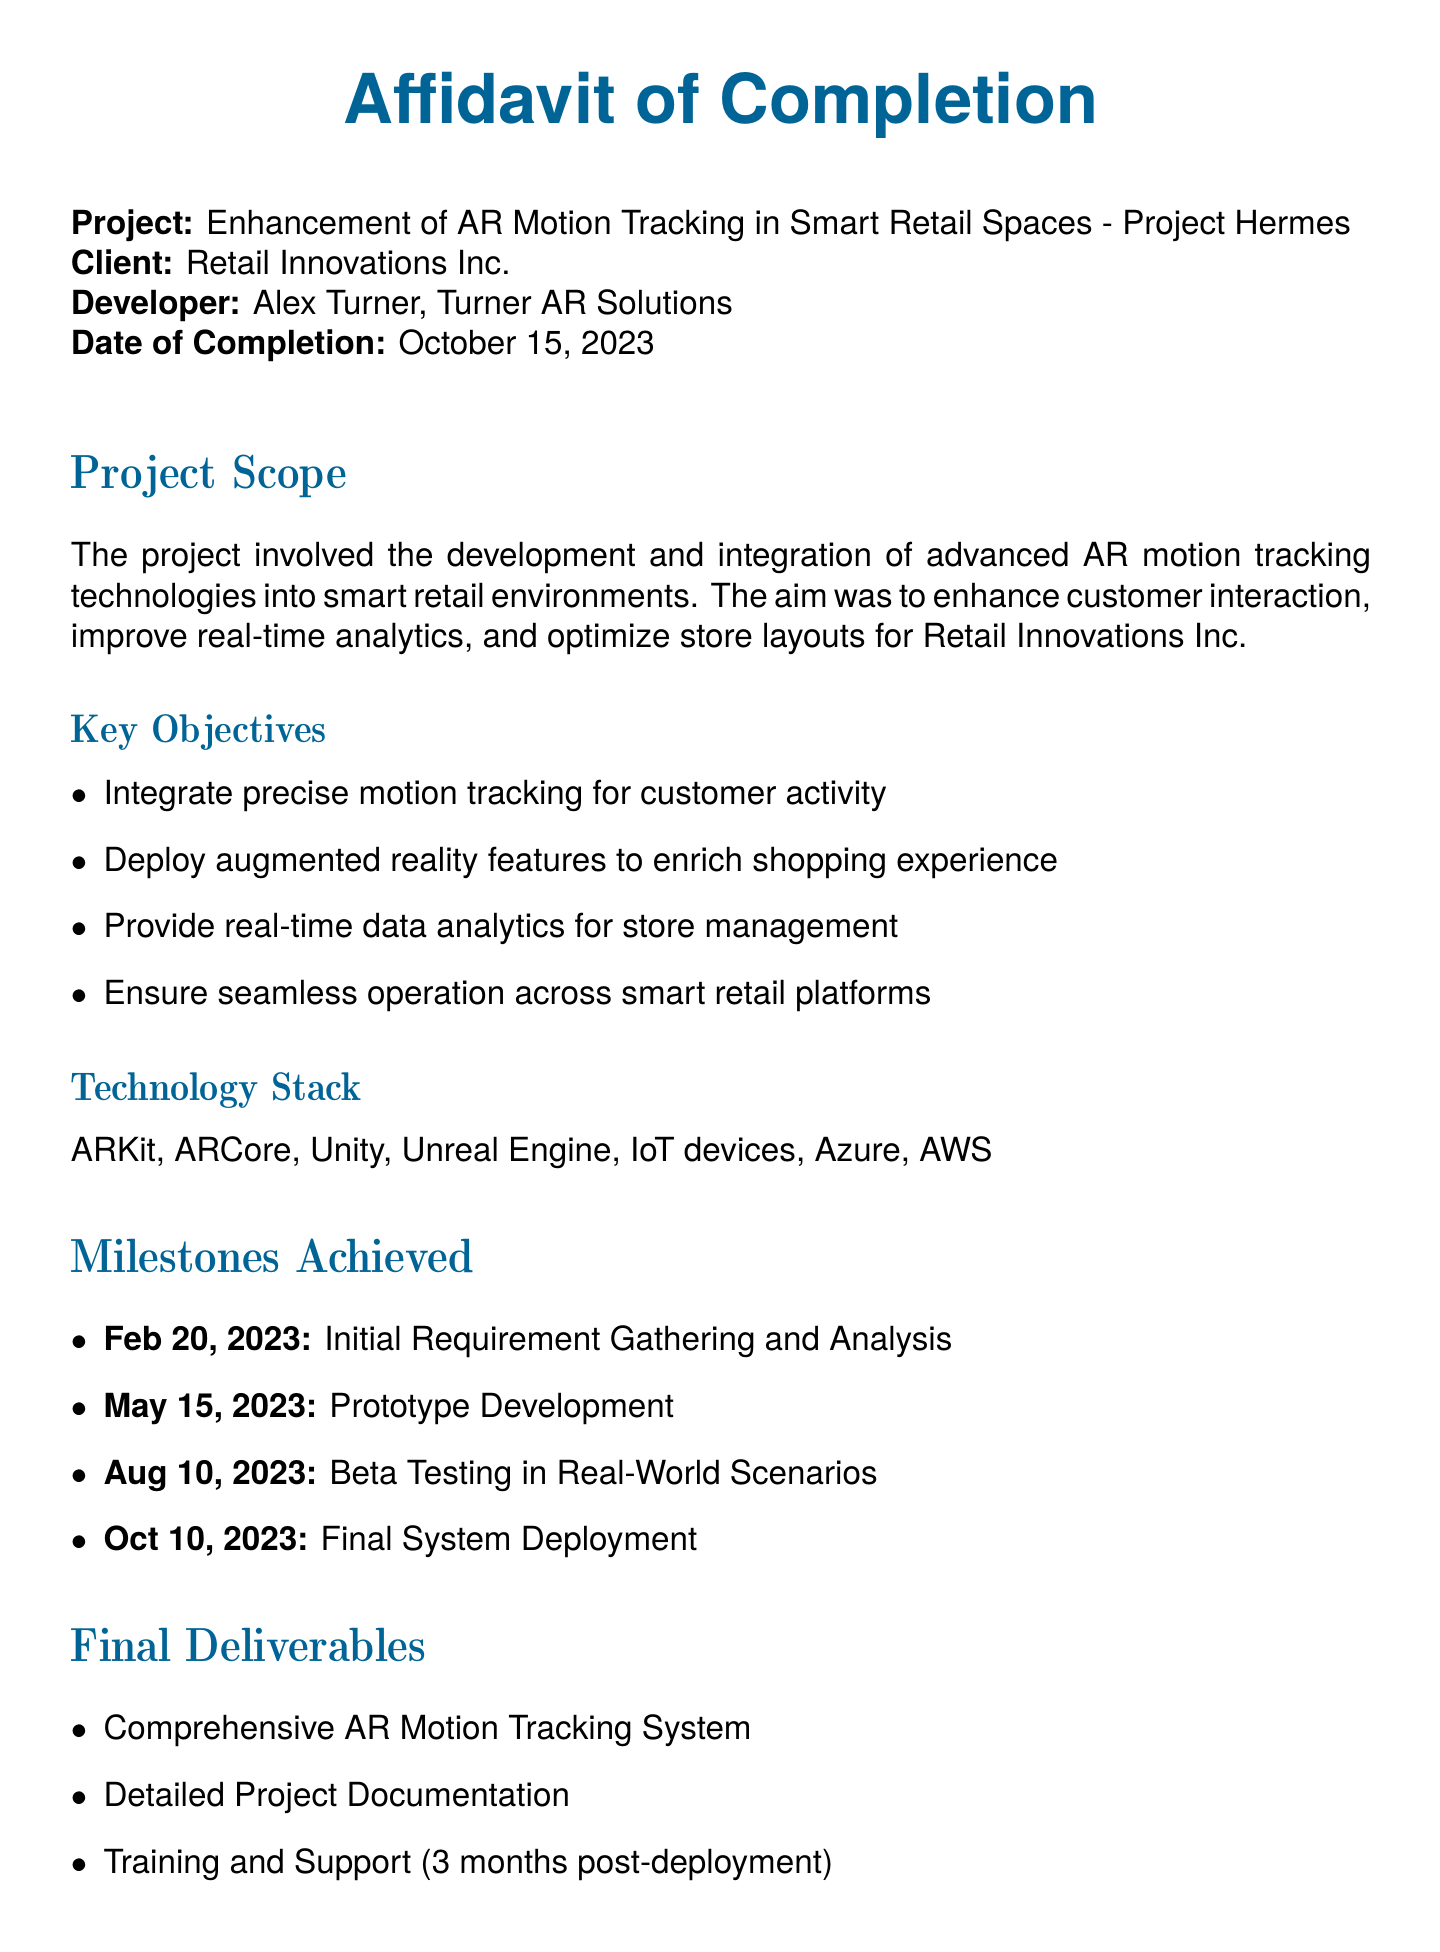what is the project title? The project title is stated at the beginning of the document as "Enhancement of AR Motion Tracking in Smart Retail Spaces - Project Hermes."
Answer: Enhancement of AR Motion Tracking in Smart Retail Spaces - Project Hermes who is the client? The client is mentioned directly in the document as Retail Innovations Inc.
Answer: Retail Innovations Inc what is the date of completion? The date of completion is provided in the document as October 15, 2023.
Answer: October 15, 2023 what technology stack was used? The technology stack is listed in the project scope section and includes various technologies for AR motion tracking.
Answer: ARKit, ARCore, Unity, Unreal Engine, IoT devices, Azure, AWS which milestone was achieved on August 10, 2023? A specific milestone achieved on August 10, 2023 is stated in the milestones section.
Answer: Beta Testing in Real-World Scenarios how long is the training and support provided after deployment? The duration of the training and support is specified in the final deliverables section.
Answer: 3 months post-deployment who signed the affidavit? The individual who signed the affidavit is clearly indicated at the end of the document.
Answer: Alex Turner what was one of the key objectives of the project? The document lists multiple key objectives, focusing on improving customer interaction and analytics.
Answer: Integrate precise motion tracking for customer activity 